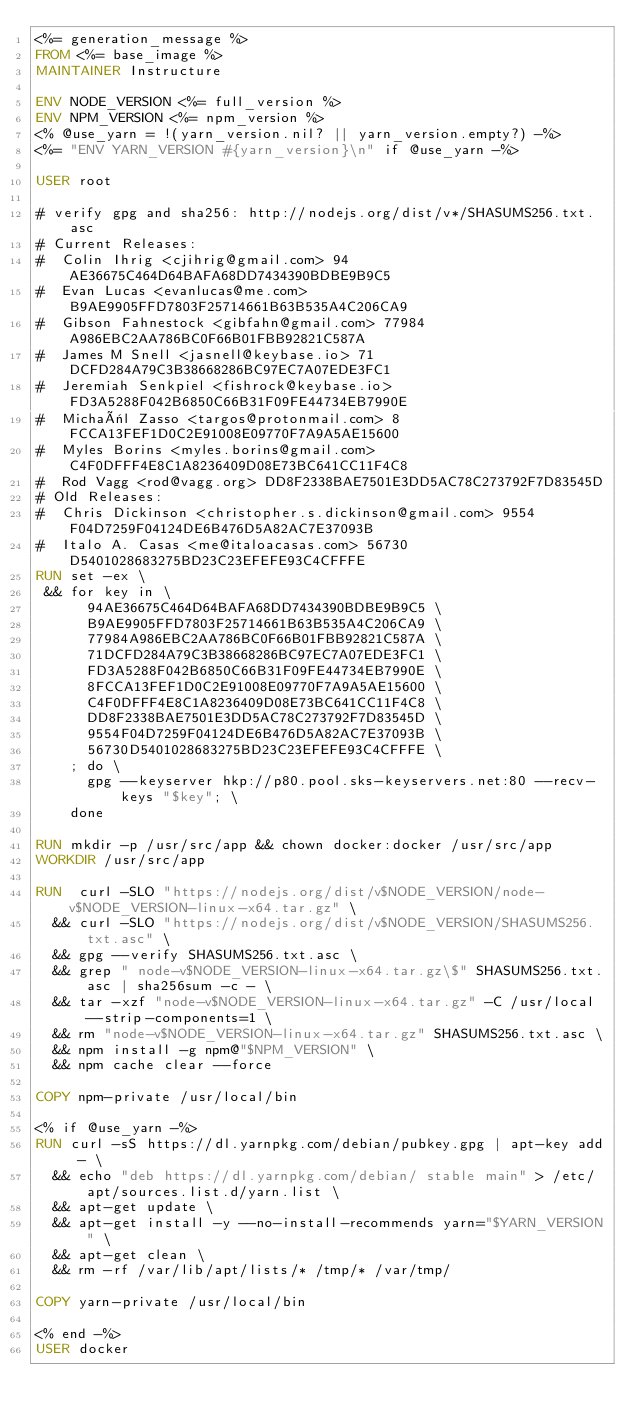<code> <loc_0><loc_0><loc_500><loc_500><_Dockerfile_><%= generation_message %>
FROM <%= base_image %>
MAINTAINER Instructure

ENV NODE_VERSION <%= full_version %>
ENV NPM_VERSION <%= npm_version %>
<% @use_yarn = !(yarn_version.nil? || yarn_version.empty?) -%>
<%= "ENV YARN_VERSION #{yarn_version}\n" if @use_yarn -%>

USER root

# verify gpg and sha256: http://nodejs.org/dist/v*/SHASUMS256.txt.asc
# Current Releases:
#  Colin Ihrig <cjihrig@gmail.com> 94AE36675C464D64BAFA68DD7434390BDBE9B9C5
#  Evan Lucas <evanlucas@me.com> B9AE9905FFD7803F25714661B63B535A4C206CA9
#  Gibson Fahnestock <gibfahn@gmail.com> 77984A986EBC2AA786BC0F66B01FBB92821C587A
#  James M Snell <jasnell@keybase.io> 71DCFD284A79C3B38668286BC97EC7A07EDE3FC1
#  Jeremiah Senkpiel <fishrock@keybase.io> FD3A5288F042B6850C66B31F09FE44734EB7990E
#  Michaël Zasso <targos@protonmail.com> 8FCCA13FEF1D0C2E91008E09770F7A9A5AE15600
#  Myles Borins <myles.borins@gmail.com> C4F0DFFF4E8C1A8236409D08E73BC641CC11F4C8
#  Rod Vagg <rod@vagg.org> DD8F2338BAE7501E3DD5AC78C273792F7D83545D
# Old Releases:
#  Chris Dickinson <christopher.s.dickinson@gmail.com> 9554F04D7259F04124DE6B476D5A82AC7E37093B
#  Italo A. Casas <me@italoacasas.com> 56730D5401028683275BD23C23EFEFE93C4CFFFE
RUN set -ex \
 && for key in \
      94AE36675C464D64BAFA68DD7434390BDBE9B9C5 \
      B9AE9905FFD7803F25714661B63B535A4C206CA9 \
      77984A986EBC2AA786BC0F66B01FBB92821C587A \
      71DCFD284A79C3B38668286BC97EC7A07EDE3FC1 \
      FD3A5288F042B6850C66B31F09FE44734EB7990E \
      8FCCA13FEF1D0C2E91008E09770F7A9A5AE15600 \
      C4F0DFFF4E8C1A8236409D08E73BC641CC11F4C8 \
      DD8F2338BAE7501E3DD5AC78C273792F7D83545D \
      9554F04D7259F04124DE6B476D5A82AC7E37093B \
      56730D5401028683275BD23C23EFEFE93C4CFFFE \
    ; do \
      gpg --keyserver hkp://p80.pool.sks-keyservers.net:80 --recv-keys "$key"; \
    done

RUN mkdir -p /usr/src/app && chown docker:docker /usr/src/app
WORKDIR /usr/src/app

RUN  curl -SLO "https://nodejs.org/dist/v$NODE_VERSION/node-v$NODE_VERSION-linux-x64.tar.gz" \
  && curl -SLO "https://nodejs.org/dist/v$NODE_VERSION/SHASUMS256.txt.asc" \
  && gpg --verify SHASUMS256.txt.asc \
  && grep " node-v$NODE_VERSION-linux-x64.tar.gz\$" SHASUMS256.txt.asc | sha256sum -c - \
  && tar -xzf "node-v$NODE_VERSION-linux-x64.tar.gz" -C /usr/local --strip-components=1 \
  && rm "node-v$NODE_VERSION-linux-x64.tar.gz" SHASUMS256.txt.asc \
  && npm install -g npm@"$NPM_VERSION" \
  && npm cache clear --force

COPY npm-private /usr/local/bin

<% if @use_yarn -%>
RUN curl -sS https://dl.yarnpkg.com/debian/pubkey.gpg | apt-key add - \
  && echo "deb https://dl.yarnpkg.com/debian/ stable main" > /etc/apt/sources.list.d/yarn.list \
  && apt-get update \
  && apt-get install -y --no-install-recommends yarn="$YARN_VERSION" \
  && apt-get clean \
  && rm -rf /var/lib/apt/lists/* /tmp/* /var/tmp/

COPY yarn-private /usr/local/bin

<% end -%>
USER docker
</code> 